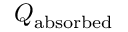Convert formula to latex. <formula><loc_0><loc_0><loc_500><loc_500>Q _ { a b s o r b e d }</formula> 